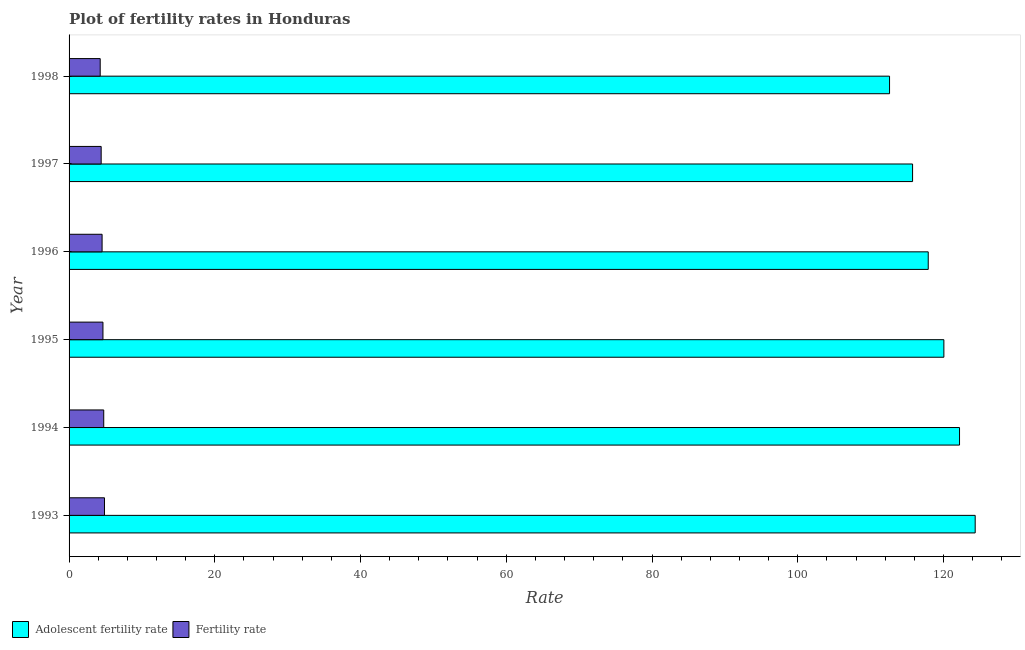Are the number of bars per tick equal to the number of legend labels?
Give a very brief answer. Yes. How many bars are there on the 1st tick from the top?
Offer a terse response. 2. In how many cases, is the number of bars for a given year not equal to the number of legend labels?
Keep it short and to the point. 0. What is the fertility rate in 1995?
Provide a succinct answer. 4.65. Across all years, what is the maximum adolescent fertility rate?
Provide a short and direct response. 124.35. Across all years, what is the minimum fertility rate?
Offer a terse response. 4.27. In which year was the adolescent fertility rate maximum?
Provide a succinct answer. 1993. In which year was the adolescent fertility rate minimum?
Your response must be concise. 1998. What is the total fertility rate in the graph?
Ensure brevity in your answer.  27.48. What is the difference between the fertility rate in 1995 and that in 1996?
Ensure brevity in your answer.  0.12. What is the difference between the adolescent fertility rate in 1998 and the fertility rate in 1997?
Offer a very short reply. 108.19. What is the average adolescent fertility rate per year?
Your answer should be compact. 118.81. In the year 1995, what is the difference between the adolescent fertility rate and fertility rate?
Provide a short and direct response. 115.41. What is the ratio of the adolescent fertility rate in 1993 to that in 1998?
Give a very brief answer. 1.1. What is the difference between the highest and the second highest adolescent fertility rate?
Make the answer very short. 2.15. What is the difference between the highest and the lowest adolescent fertility rate?
Provide a succinct answer. 11.75. What does the 2nd bar from the top in 1997 represents?
Provide a succinct answer. Adolescent fertility rate. What does the 1st bar from the bottom in 1993 represents?
Your answer should be very brief. Adolescent fertility rate. Are all the bars in the graph horizontal?
Offer a terse response. Yes. What is the difference between two consecutive major ticks on the X-axis?
Your answer should be very brief. 20. Are the values on the major ticks of X-axis written in scientific E-notation?
Keep it short and to the point. No. Does the graph contain any zero values?
Your response must be concise. No. Does the graph contain grids?
Your answer should be compact. No. Where does the legend appear in the graph?
Give a very brief answer. Bottom left. What is the title of the graph?
Your answer should be very brief. Plot of fertility rates in Honduras. What is the label or title of the X-axis?
Your response must be concise. Rate. What is the label or title of the Y-axis?
Give a very brief answer. Year. What is the Rate in Adolescent fertility rate in 1993?
Your response must be concise. 124.35. What is the Rate in Fertility rate in 1993?
Offer a very short reply. 4.86. What is the Rate in Adolescent fertility rate in 1994?
Your answer should be very brief. 122.2. What is the Rate in Fertility rate in 1994?
Your answer should be very brief. 4.76. What is the Rate of Adolescent fertility rate in 1995?
Your answer should be compact. 120.06. What is the Rate of Fertility rate in 1995?
Ensure brevity in your answer.  4.65. What is the Rate of Adolescent fertility rate in 1996?
Make the answer very short. 117.91. What is the Rate in Fertility rate in 1996?
Offer a very short reply. 4.53. What is the Rate in Adolescent fertility rate in 1997?
Your answer should be compact. 115.76. What is the Rate of Fertility rate in 1997?
Provide a succinct answer. 4.41. What is the Rate of Adolescent fertility rate in 1998?
Your answer should be compact. 112.6. What is the Rate of Fertility rate in 1998?
Provide a short and direct response. 4.27. Across all years, what is the maximum Rate of Adolescent fertility rate?
Provide a succinct answer. 124.35. Across all years, what is the maximum Rate of Fertility rate?
Keep it short and to the point. 4.86. Across all years, what is the minimum Rate of Adolescent fertility rate?
Your response must be concise. 112.6. Across all years, what is the minimum Rate in Fertility rate?
Offer a very short reply. 4.27. What is the total Rate in Adolescent fertility rate in the graph?
Offer a very short reply. 712.87. What is the total Rate in Fertility rate in the graph?
Give a very brief answer. 27.48. What is the difference between the Rate in Adolescent fertility rate in 1993 and that in 1994?
Provide a short and direct response. 2.15. What is the difference between the Rate in Fertility rate in 1993 and that in 1994?
Your response must be concise. 0.1. What is the difference between the Rate in Adolescent fertility rate in 1993 and that in 1995?
Offer a terse response. 4.3. What is the difference between the Rate in Fertility rate in 1993 and that in 1995?
Your response must be concise. 0.21. What is the difference between the Rate of Adolescent fertility rate in 1993 and that in 1996?
Your answer should be compact. 6.44. What is the difference between the Rate in Fertility rate in 1993 and that in 1996?
Make the answer very short. 0.33. What is the difference between the Rate in Adolescent fertility rate in 1993 and that in 1997?
Your response must be concise. 8.59. What is the difference between the Rate of Fertility rate in 1993 and that in 1997?
Ensure brevity in your answer.  0.46. What is the difference between the Rate in Adolescent fertility rate in 1993 and that in 1998?
Your answer should be very brief. 11.75. What is the difference between the Rate in Fertility rate in 1993 and that in 1998?
Provide a short and direct response. 0.59. What is the difference between the Rate in Adolescent fertility rate in 1994 and that in 1995?
Make the answer very short. 2.15. What is the difference between the Rate of Fertility rate in 1994 and that in 1995?
Your response must be concise. 0.11. What is the difference between the Rate in Adolescent fertility rate in 1994 and that in 1996?
Offer a very short reply. 4.3. What is the difference between the Rate in Fertility rate in 1994 and that in 1996?
Your answer should be compact. 0.23. What is the difference between the Rate of Adolescent fertility rate in 1994 and that in 1997?
Make the answer very short. 6.44. What is the difference between the Rate of Fertility rate in 1994 and that in 1997?
Your answer should be very brief. 0.35. What is the difference between the Rate in Adolescent fertility rate in 1994 and that in 1998?
Give a very brief answer. 9.6. What is the difference between the Rate of Fertility rate in 1994 and that in 1998?
Your answer should be compact. 0.49. What is the difference between the Rate in Adolescent fertility rate in 1995 and that in 1996?
Keep it short and to the point. 2.15. What is the difference between the Rate of Fertility rate in 1995 and that in 1996?
Ensure brevity in your answer.  0.12. What is the difference between the Rate in Adolescent fertility rate in 1995 and that in 1997?
Give a very brief answer. 4.3. What is the difference between the Rate in Fertility rate in 1995 and that in 1997?
Offer a terse response. 0.24. What is the difference between the Rate in Adolescent fertility rate in 1995 and that in 1998?
Offer a very short reply. 7.46. What is the difference between the Rate in Fertility rate in 1995 and that in 1998?
Provide a short and direct response. 0.38. What is the difference between the Rate in Adolescent fertility rate in 1996 and that in 1997?
Ensure brevity in your answer.  2.15. What is the difference between the Rate of Fertility rate in 1996 and that in 1997?
Offer a very short reply. 0.13. What is the difference between the Rate in Adolescent fertility rate in 1996 and that in 1998?
Keep it short and to the point. 5.31. What is the difference between the Rate in Fertility rate in 1996 and that in 1998?
Offer a terse response. 0.26. What is the difference between the Rate of Adolescent fertility rate in 1997 and that in 1998?
Your answer should be compact. 3.16. What is the difference between the Rate of Fertility rate in 1997 and that in 1998?
Ensure brevity in your answer.  0.13. What is the difference between the Rate in Adolescent fertility rate in 1993 and the Rate in Fertility rate in 1994?
Provide a short and direct response. 119.59. What is the difference between the Rate of Adolescent fertility rate in 1993 and the Rate of Fertility rate in 1995?
Your response must be concise. 119.7. What is the difference between the Rate of Adolescent fertility rate in 1993 and the Rate of Fertility rate in 1996?
Make the answer very short. 119.82. What is the difference between the Rate of Adolescent fertility rate in 1993 and the Rate of Fertility rate in 1997?
Provide a short and direct response. 119.95. What is the difference between the Rate in Adolescent fertility rate in 1993 and the Rate in Fertility rate in 1998?
Provide a short and direct response. 120.08. What is the difference between the Rate of Adolescent fertility rate in 1994 and the Rate of Fertility rate in 1995?
Ensure brevity in your answer.  117.55. What is the difference between the Rate of Adolescent fertility rate in 1994 and the Rate of Fertility rate in 1996?
Your answer should be compact. 117.67. What is the difference between the Rate of Adolescent fertility rate in 1994 and the Rate of Fertility rate in 1997?
Your answer should be compact. 117.8. What is the difference between the Rate in Adolescent fertility rate in 1994 and the Rate in Fertility rate in 1998?
Offer a very short reply. 117.93. What is the difference between the Rate of Adolescent fertility rate in 1995 and the Rate of Fertility rate in 1996?
Make the answer very short. 115.52. What is the difference between the Rate in Adolescent fertility rate in 1995 and the Rate in Fertility rate in 1997?
Keep it short and to the point. 115.65. What is the difference between the Rate of Adolescent fertility rate in 1995 and the Rate of Fertility rate in 1998?
Your answer should be compact. 115.78. What is the difference between the Rate in Adolescent fertility rate in 1996 and the Rate in Fertility rate in 1997?
Make the answer very short. 113.5. What is the difference between the Rate of Adolescent fertility rate in 1996 and the Rate of Fertility rate in 1998?
Your answer should be compact. 113.64. What is the difference between the Rate in Adolescent fertility rate in 1997 and the Rate in Fertility rate in 1998?
Keep it short and to the point. 111.49. What is the average Rate in Adolescent fertility rate per year?
Provide a succinct answer. 118.81. What is the average Rate in Fertility rate per year?
Make the answer very short. 4.58. In the year 1993, what is the difference between the Rate of Adolescent fertility rate and Rate of Fertility rate?
Provide a short and direct response. 119.49. In the year 1994, what is the difference between the Rate of Adolescent fertility rate and Rate of Fertility rate?
Offer a very short reply. 117.44. In the year 1995, what is the difference between the Rate of Adolescent fertility rate and Rate of Fertility rate?
Make the answer very short. 115.41. In the year 1996, what is the difference between the Rate of Adolescent fertility rate and Rate of Fertility rate?
Your response must be concise. 113.38. In the year 1997, what is the difference between the Rate of Adolescent fertility rate and Rate of Fertility rate?
Keep it short and to the point. 111.35. In the year 1998, what is the difference between the Rate in Adolescent fertility rate and Rate in Fertility rate?
Provide a succinct answer. 108.33. What is the ratio of the Rate in Adolescent fertility rate in 1993 to that in 1994?
Your response must be concise. 1.02. What is the ratio of the Rate of Fertility rate in 1993 to that in 1994?
Ensure brevity in your answer.  1.02. What is the ratio of the Rate in Adolescent fertility rate in 1993 to that in 1995?
Offer a terse response. 1.04. What is the ratio of the Rate of Fertility rate in 1993 to that in 1995?
Offer a very short reply. 1.05. What is the ratio of the Rate in Adolescent fertility rate in 1993 to that in 1996?
Keep it short and to the point. 1.05. What is the ratio of the Rate of Fertility rate in 1993 to that in 1996?
Ensure brevity in your answer.  1.07. What is the ratio of the Rate in Adolescent fertility rate in 1993 to that in 1997?
Ensure brevity in your answer.  1.07. What is the ratio of the Rate in Fertility rate in 1993 to that in 1997?
Offer a terse response. 1.1. What is the ratio of the Rate in Adolescent fertility rate in 1993 to that in 1998?
Make the answer very short. 1.1. What is the ratio of the Rate in Fertility rate in 1993 to that in 1998?
Provide a succinct answer. 1.14. What is the ratio of the Rate of Adolescent fertility rate in 1994 to that in 1995?
Offer a terse response. 1.02. What is the ratio of the Rate of Fertility rate in 1994 to that in 1995?
Offer a very short reply. 1.02. What is the ratio of the Rate of Adolescent fertility rate in 1994 to that in 1996?
Offer a terse response. 1.04. What is the ratio of the Rate in Fertility rate in 1994 to that in 1996?
Provide a succinct answer. 1.05. What is the ratio of the Rate of Adolescent fertility rate in 1994 to that in 1997?
Your answer should be very brief. 1.06. What is the ratio of the Rate of Fertility rate in 1994 to that in 1997?
Provide a succinct answer. 1.08. What is the ratio of the Rate in Adolescent fertility rate in 1994 to that in 1998?
Provide a short and direct response. 1.09. What is the ratio of the Rate in Fertility rate in 1994 to that in 1998?
Keep it short and to the point. 1.11. What is the ratio of the Rate in Adolescent fertility rate in 1995 to that in 1996?
Offer a terse response. 1.02. What is the ratio of the Rate in Adolescent fertility rate in 1995 to that in 1997?
Ensure brevity in your answer.  1.04. What is the ratio of the Rate of Fertility rate in 1995 to that in 1997?
Your response must be concise. 1.06. What is the ratio of the Rate of Adolescent fertility rate in 1995 to that in 1998?
Your answer should be compact. 1.07. What is the ratio of the Rate of Fertility rate in 1995 to that in 1998?
Your response must be concise. 1.09. What is the ratio of the Rate in Adolescent fertility rate in 1996 to that in 1997?
Give a very brief answer. 1.02. What is the ratio of the Rate of Fertility rate in 1996 to that in 1997?
Ensure brevity in your answer.  1.03. What is the ratio of the Rate of Adolescent fertility rate in 1996 to that in 1998?
Keep it short and to the point. 1.05. What is the ratio of the Rate of Fertility rate in 1996 to that in 1998?
Give a very brief answer. 1.06. What is the ratio of the Rate in Adolescent fertility rate in 1997 to that in 1998?
Provide a succinct answer. 1.03. What is the ratio of the Rate of Fertility rate in 1997 to that in 1998?
Offer a very short reply. 1.03. What is the difference between the highest and the second highest Rate of Adolescent fertility rate?
Make the answer very short. 2.15. What is the difference between the highest and the second highest Rate of Fertility rate?
Offer a terse response. 0.1. What is the difference between the highest and the lowest Rate in Adolescent fertility rate?
Your answer should be very brief. 11.75. What is the difference between the highest and the lowest Rate of Fertility rate?
Offer a very short reply. 0.59. 